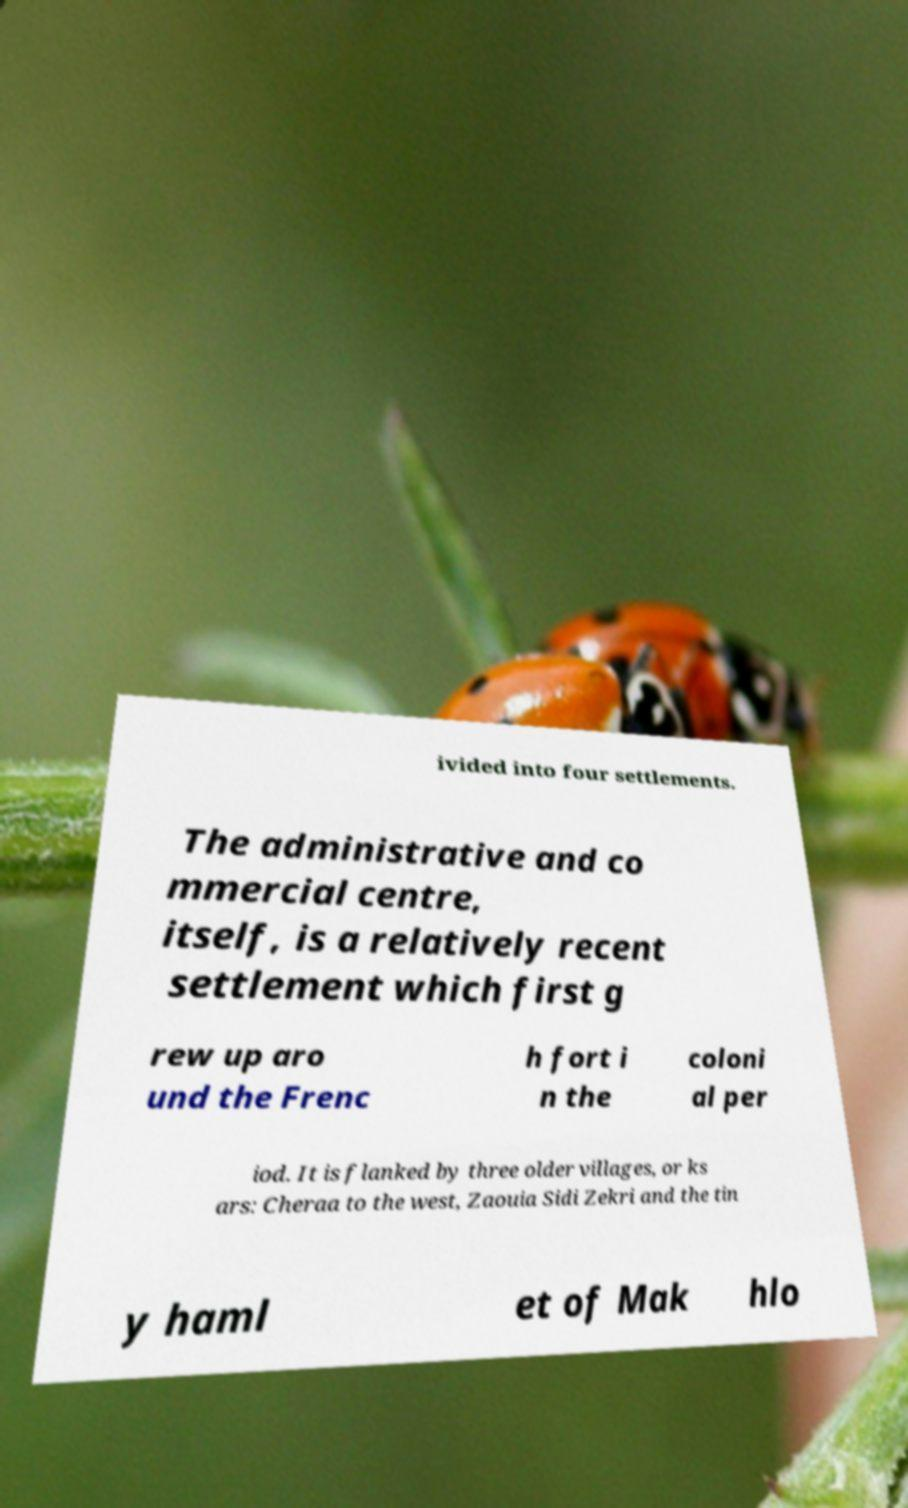Can you accurately transcribe the text from the provided image for me? ivided into four settlements. The administrative and co mmercial centre, itself, is a relatively recent settlement which first g rew up aro und the Frenc h fort i n the coloni al per iod. It is flanked by three older villages, or ks ars: Cheraa to the west, Zaouia Sidi Zekri and the tin y haml et of Mak hlo 